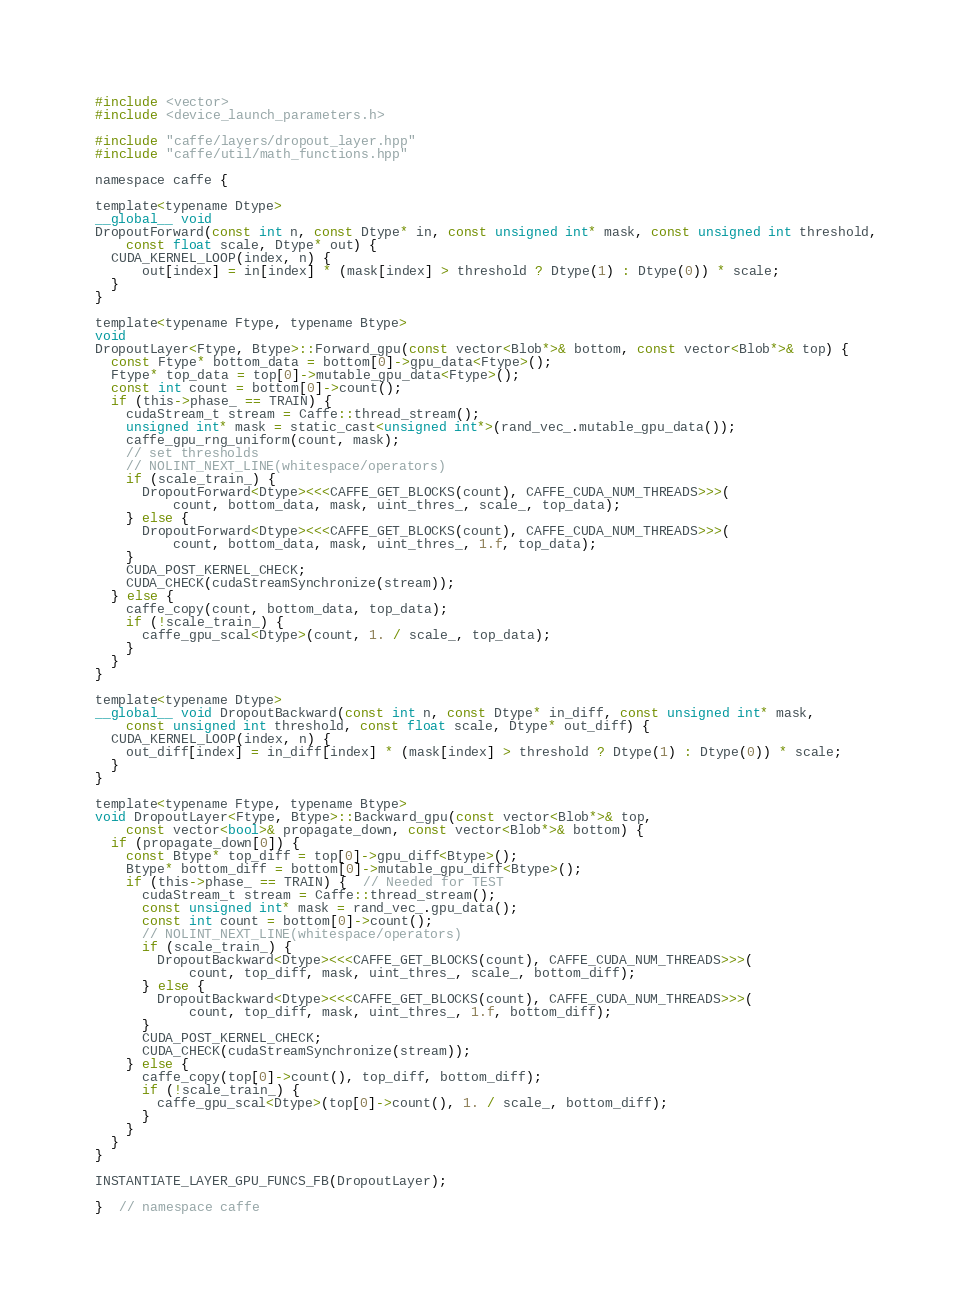Convert code to text. <code><loc_0><loc_0><loc_500><loc_500><_Cuda_>#include <vector>
#include <device_launch_parameters.h>

#include "caffe/layers/dropout_layer.hpp"
#include "caffe/util/math_functions.hpp"

namespace caffe {

template<typename Dtype>
__global__ void
DropoutForward(const int n, const Dtype* in, const unsigned int* mask, const unsigned int threshold,
    const float scale, Dtype* out) {
  CUDA_KERNEL_LOOP(index, n) {
      out[index] = in[index] * (mask[index] > threshold ? Dtype(1) : Dtype(0)) * scale;
  }
}

template<typename Ftype, typename Btype>
void
DropoutLayer<Ftype, Btype>::Forward_gpu(const vector<Blob*>& bottom, const vector<Blob*>& top) {
  const Ftype* bottom_data = bottom[0]->gpu_data<Ftype>();
  Ftype* top_data = top[0]->mutable_gpu_data<Ftype>();
  const int count = bottom[0]->count();
  if (this->phase_ == TRAIN) {
    cudaStream_t stream = Caffe::thread_stream();
    unsigned int* mask = static_cast<unsigned int*>(rand_vec_.mutable_gpu_data());
    caffe_gpu_rng_uniform(count, mask);
    // set thresholds
    // NOLINT_NEXT_LINE(whitespace/operators)
    if (scale_train_) {
      DropoutForward<Dtype><<<CAFFE_GET_BLOCKS(count), CAFFE_CUDA_NUM_THREADS>>>(
          count, bottom_data, mask, uint_thres_, scale_, top_data);
    } else {
      DropoutForward<Dtype><<<CAFFE_GET_BLOCKS(count), CAFFE_CUDA_NUM_THREADS>>>(
          count, bottom_data, mask, uint_thres_, 1.f, top_data);
    }
    CUDA_POST_KERNEL_CHECK;
    CUDA_CHECK(cudaStreamSynchronize(stream));
  } else {
    caffe_copy(count, bottom_data, top_data);
    if (!scale_train_) {
      caffe_gpu_scal<Dtype>(count, 1. / scale_, top_data);
    }
  }
}

template<typename Dtype>
__global__ void DropoutBackward(const int n, const Dtype* in_diff, const unsigned int* mask,
    const unsigned int threshold, const float scale, Dtype* out_diff) {
  CUDA_KERNEL_LOOP(index, n) {
    out_diff[index] = in_diff[index] * (mask[index] > threshold ? Dtype(1) : Dtype(0)) * scale;
  }
}

template<typename Ftype, typename Btype>
void DropoutLayer<Ftype, Btype>::Backward_gpu(const vector<Blob*>& top,
    const vector<bool>& propagate_down, const vector<Blob*>& bottom) {
  if (propagate_down[0]) {
    const Btype* top_diff = top[0]->gpu_diff<Btype>();
    Btype* bottom_diff = bottom[0]->mutable_gpu_diff<Btype>();
    if (this->phase_ == TRAIN) {  // Needed for TEST
      cudaStream_t stream = Caffe::thread_stream();
      const unsigned int* mask = rand_vec_.gpu_data();
      const int count = bottom[0]->count();
      // NOLINT_NEXT_LINE(whitespace/operators)
      if (scale_train_) {
        DropoutBackward<Dtype><<<CAFFE_GET_BLOCKS(count), CAFFE_CUDA_NUM_THREADS>>>(
            count, top_diff, mask, uint_thres_, scale_, bottom_diff);
      } else {
        DropoutBackward<Dtype><<<CAFFE_GET_BLOCKS(count), CAFFE_CUDA_NUM_THREADS>>>(
            count, top_diff, mask, uint_thres_, 1.f, bottom_diff);
      }
      CUDA_POST_KERNEL_CHECK;
      CUDA_CHECK(cudaStreamSynchronize(stream));
    } else {
      caffe_copy(top[0]->count(), top_diff, bottom_diff);
      if (!scale_train_) {
        caffe_gpu_scal<Dtype>(top[0]->count(), 1. / scale_, bottom_diff);
      }
    }
  }
}

INSTANTIATE_LAYER_GPU_FUNCS_FB(DropoutLayer);

}  // namespace caffe
</code> 